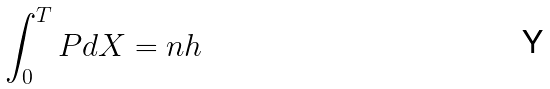Convert formula to latex. <formula><loc_0><loc_0><loc_500><loc_500>\int _ { 0 } ^ { T } P d X = n h</formula> 